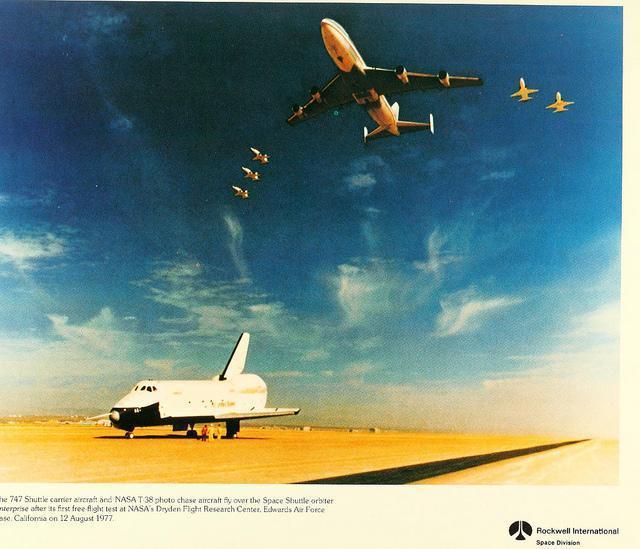How many jets are there?
Give a very brief answer. 6. How many airplanes are there?
Give a very brief answer. 2. 